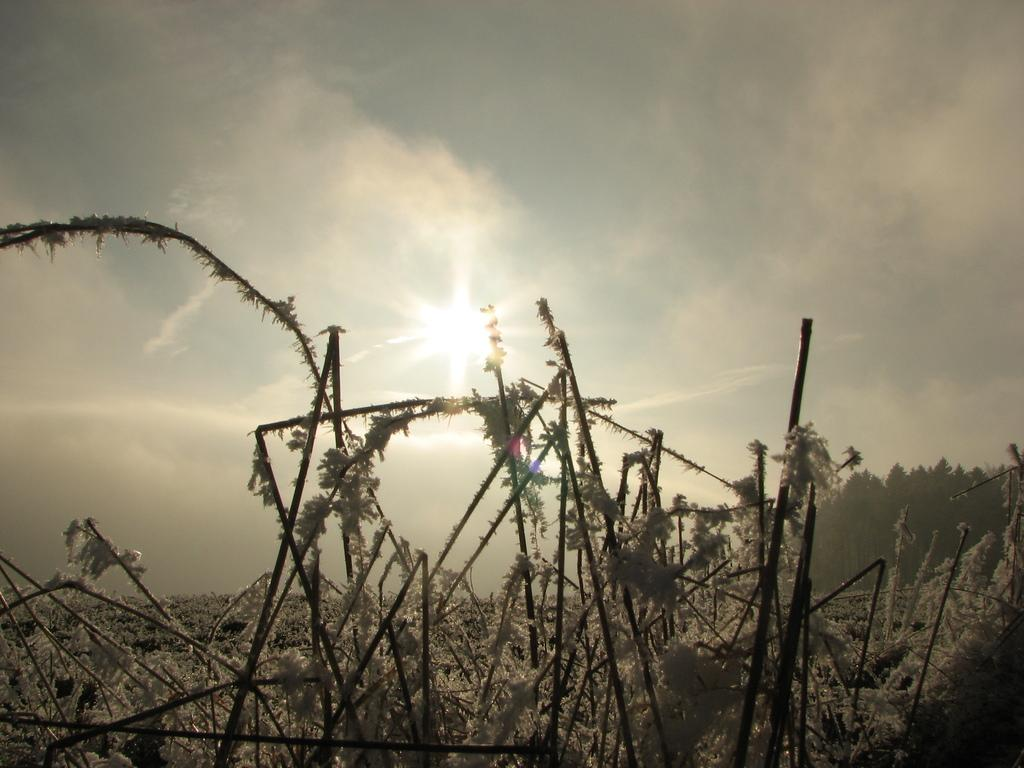What is covering the twigs in the image? The twigs are covered by ice in the image. What can be seen in the background of the image? There are trees in the background of the image. What is the source of light in the image? Sunlight is visible in the image. What is the size of the knee in the image? There is no knee present in the image; it features twigs covered by ice and trees in the background. 